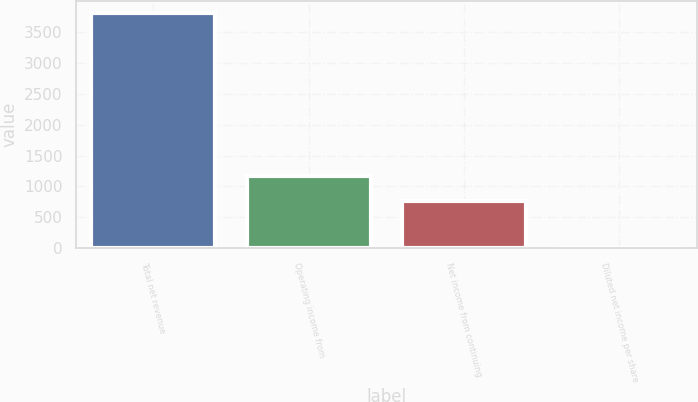Convert chart. <chart><loc_0><loc_0><loc_500><loc_500><bar_chart><fcel>Total net revenue<fcel>Operating income from<fcel>Net income from continuing<fcel>Diluted net income per share<nl><fcel>3808<fcel>1168<fcel>764<fcel>2.51<nl></chart> 